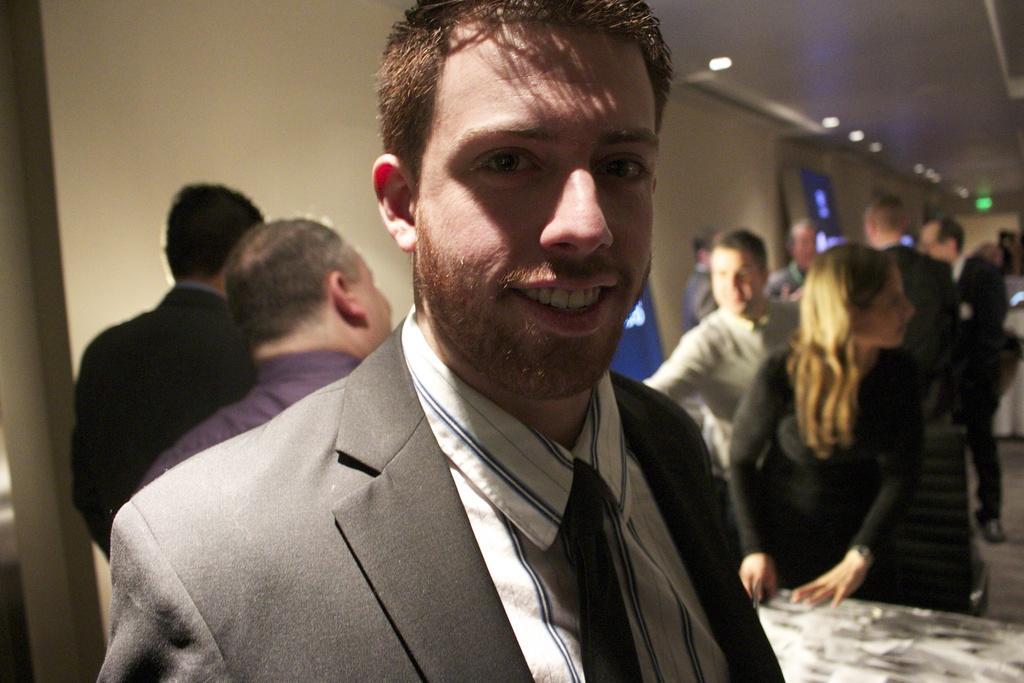Describe this image in one or two sentences. In this image there are a group of people standing, and in the foreground there is one person who is wearing a suit and smiling. And on the right side of the image there might be a table and there are some boards, lights and wall and at the top there is ceiling. 